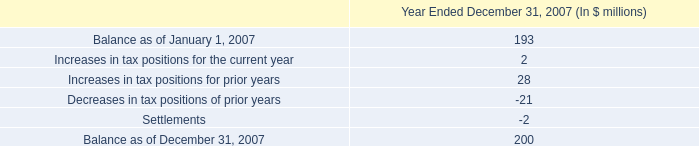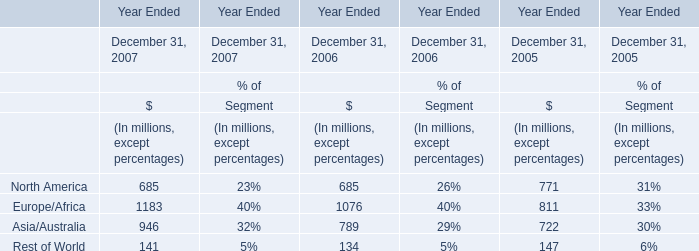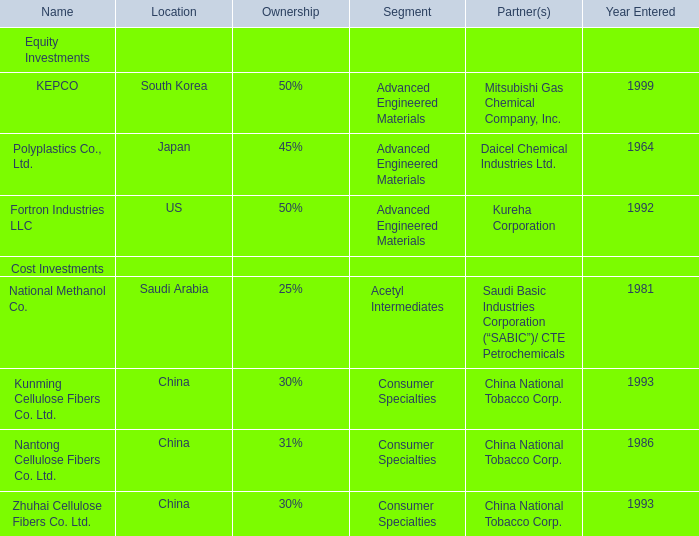What's the total amount of the value in 2006 in the area where percentage proportion is greater than 35% in 2007? (in dollars in millions) 
Answer: 1076. 